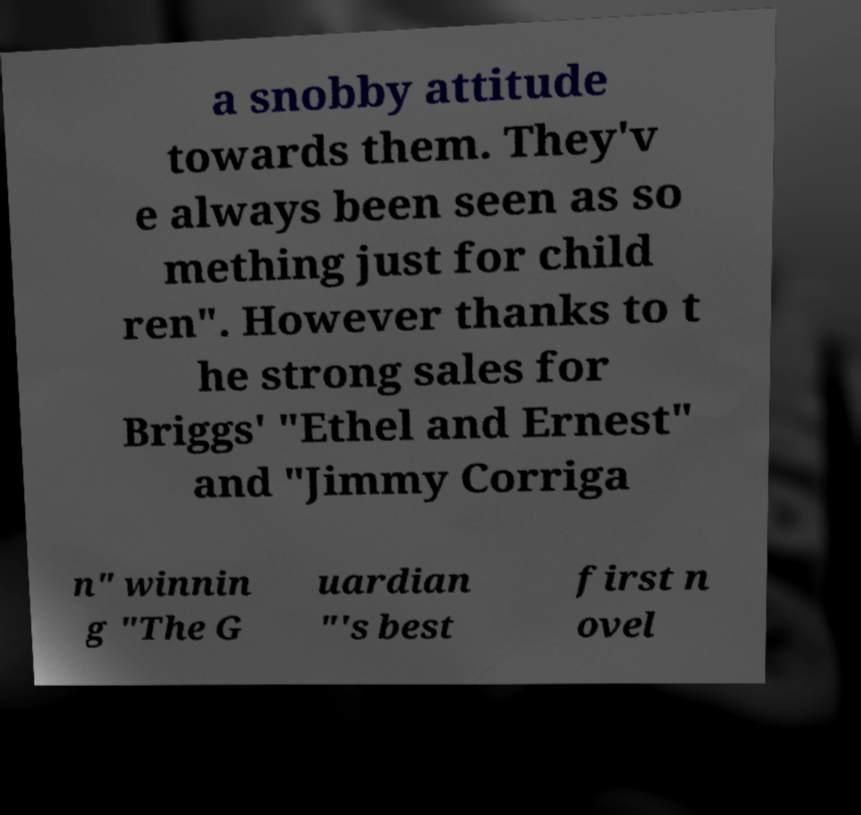I need the written content from this picture converted into text. Can you do that? a snobby attitude towards them. They'v e always been seen as so mething just for child ren". However thanks to t he strong sales for Briggs' "Ethel and Ernest" and "Jimmy Corriga n" winnin g "The G uardian "'s best first n ovel 